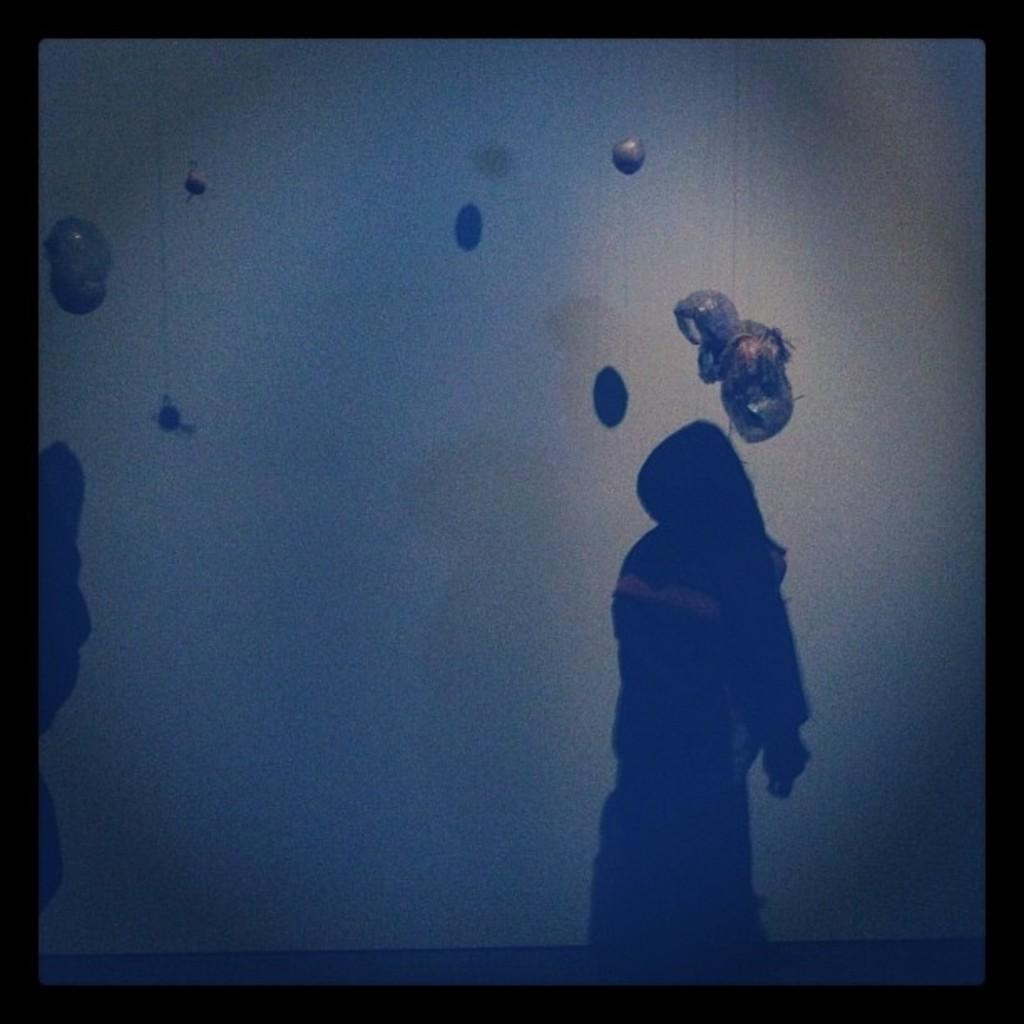Could you give a brief overview of what you see in this image? In this image I can see the dark picture in which I can see the shadow of the person and few objects in the air. I can see the black colored boundaries to the picture. 